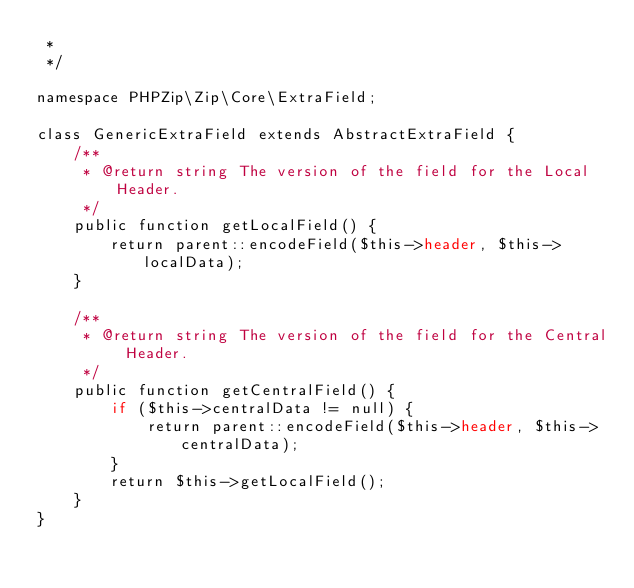Convert code to text. <code><loc_0><loc_0><loc_500><loc_500><_PHP_> *
 */

namespace PHPZip\Zip\Core\ExtraField;

class GenericExtraField extends AbstractExtraField {
	/**
	 * @return string The version of the field for the Local Header.
	 */
	public function getLocalField() {
        return parent::encodeField($this->header, $this->localData);
	}

	/**
	 * @return string The version of the field for the Central Header.
	 */
	public function getCentralField() {
        if ($this->centralData != null) {
            return parent::encodeField($this->header, $this->centralData);
        }
		return $this->getLocalField();		
	}
}
</code> 